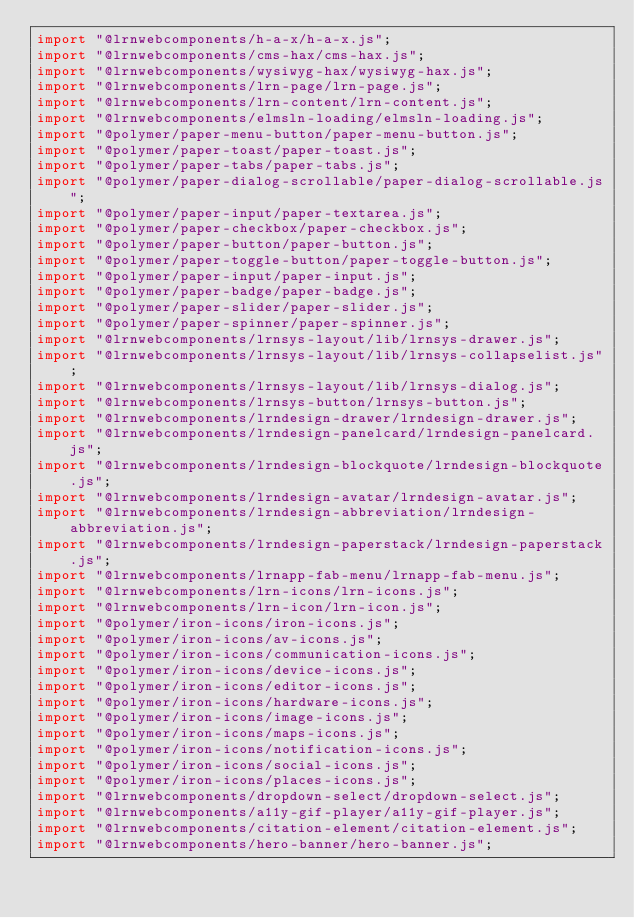<code> <loc_0><loc_0><loc_500><loc_500><_JavaScript_>import "@lrnwebcomponents/h-a-x/h-a-x.js";
import "@lrnwebcomponents/cms-hax/cms-hax.js";
import "@lrnwebcomponents/wysiwyg-hax/wysiwyg-hax.js";
import "@lrnwebcomponents/lrn-page/lrn-page.js";
import "@lrnwebcomponents/lrn-content/lrn-content.js";
import "@lrnwebcomponents/elmsln-loading/elmsln-loading.js";
import "@polymer/paper-menu-button/paper-menu-button.js";
import "@polymer/paper-toast/paper-toast.js";
import "@polymer/paper-tabs/paper-tabs.js";
import "@polymer/paper-dialog-scrollable/paper-dialog-scrollable.js";
import "@polymer/paper-input/paper-textarea.js";
import "@polymer/paper-checkbox/paper-checkbox.js";
import "@polymer/paper-button/paper-button.js";
import "@polymer/paper-toggle-button/paper-toggle-button.js";
import "@polymer/paper-input/paper-input.js";
import "@polymer/paper-badge/paper-badge.js";
import "@polymer/paper-slider/paper-slider.js";
import "@polymer/paper-spinner/paper-spinner.js";
import "@lrnwebcomponents/lrnsys-layout/lib/lrnsys-drawer.js";
import "@lrnwebcomponents/lrnsys-layout/lib/lrnsys-collapselist.js";
import "@lrnwebcomponents/lrnsys-layout/lib/lrnsys-dialog.js";
import "@lrnwebcomponents/lrnsys-button/lrnsys-button.js";
import "@lrnwebcomponents/lrndesign-drawer/lrndesign-drawer.js";
import "@lrnwebcomponents/lrndesign-panelcard/lrndesign-panelcard.js";
import "@lrnwebcomponents/lrndesign-blockquote/lrndesign-blockquote.js";
import "@lrnwebcomponents/lrndesign-avatar/lrndesign-avatar.js";
import "@lrnwebcomponents/lrndesign-abbreviation/lrndesign-abbreviation.js";
import "@lrnwebcomponents/lrndesign-paperstack/lrndesign-paperstack.js";
import "@lrnwebcomponents/lrnapp-fab-menu/lrnapp-fab-menu.js";
import "@lrnwebcomponents/lrn-icons/lrn-icons.js";
import "@lrnwebcomponents/lrn-icon/lrn-icon.js";
import "@polymer/iron-icons/iron-icons.js";
import "@polymer/iron-icons/av-icons.js";
import "@polymer/iron-icons/communication-icons.js";
import "@polymer/iron-icons/device-icons.js";
import "@polymer/iron-icons/editor-icons.js";
import "@polymer/iron-icons/hardware-icons.js";
import "@polymer/iron-icons/image-icons.js";
import "@polymer/iron-icons/maps-icons.js";
import "@polymer/iron-icons/notification-icons.js";
import "@polymer/iron-icons/social-icons.js";
import "@polymer/iron-icons/places-icons.js";
import "@lrnwebcomponents/dropdown-select/dropdown-select.js";
import "@lrnwebcomponents/a11y-gif-player/a11y-gif-player.js";
import "@lrnwebcomponents/citation-element/citation-element.js";
import "@lrnwebcomponents/hero-banner/hero-banner.js";</code> 